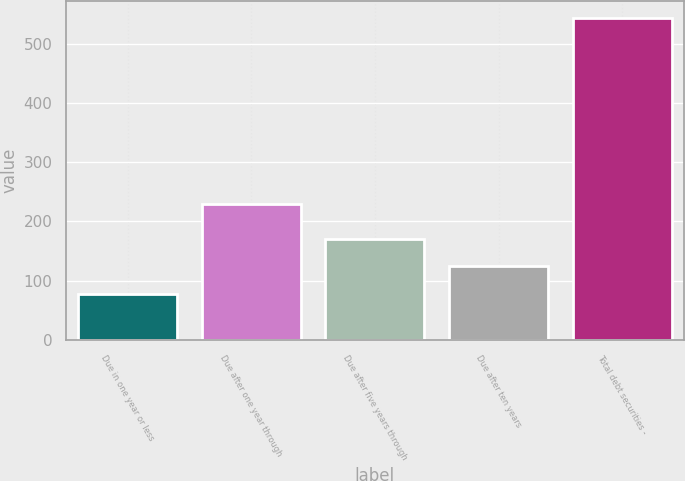<chart> <loc_0><loc_0><loc_500><loc_500><bar_chart><fcel>Due in one year or less<fcel>Due after one year through<fcel>Due after five years through<fcel>Due after ten years<fcel>Total debt securities -<nl><fcel>78<fcel>230<fcel>171.2<fcel>124.6<fcel>544<nl></chart> 